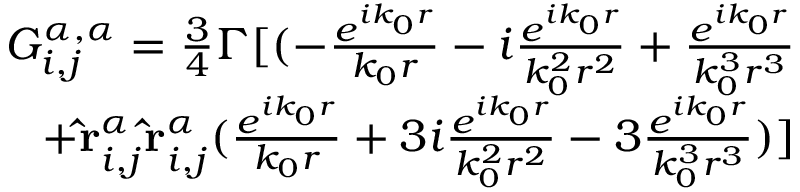Convert formula to latex. <formula><loc_0><loc_0><loc_500><loc_500>\begin{array} { r } { G _ { i , j } ^ { \alpha , \alpha } = \frac { 3 } { 4 } \Gamma [ ( - \frac { e ^ { i k _ { 0 } r } } { k _ { 0 } r } - i \frac { e ^ { i k _ { 0 } r } } { k _ { 0 } ^ { 2 } r ^ { 2 } } + \frac { e ^ { i k _ { 0 } r } } { k _ { 0 } ^ { 3 } r ^ { 3 } } } \\ { + \hat { r } _ { i , j } ^ { \alpha } \hat { r } _ { i , j } ^ { \alpha } ( \frac { e ^ { i k _ { 0 } r } } { k _ { 0 } r } + 3 i \frac { e ^ { i k _ { 0 } r } } { k _ { 0 } ^ { 2 } r ^ { 2 } } - 3 \frac { e ^ { i k _ { 0 } r } } { k _ { 0 } ^ { 3 } r ^ { 3 } } ) ] } \end{array}</formula> 